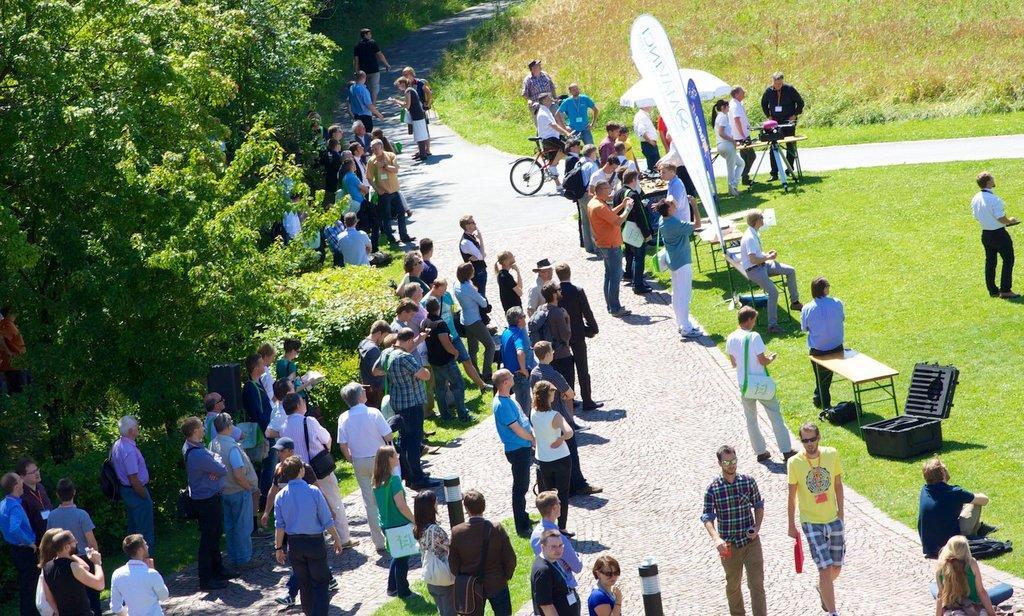Describe this image in one or two sentences. In this picture I can see there are many people standing and there is a umbrella here and a banner, there is grass on the floor and there are trees and the sky is clear. 